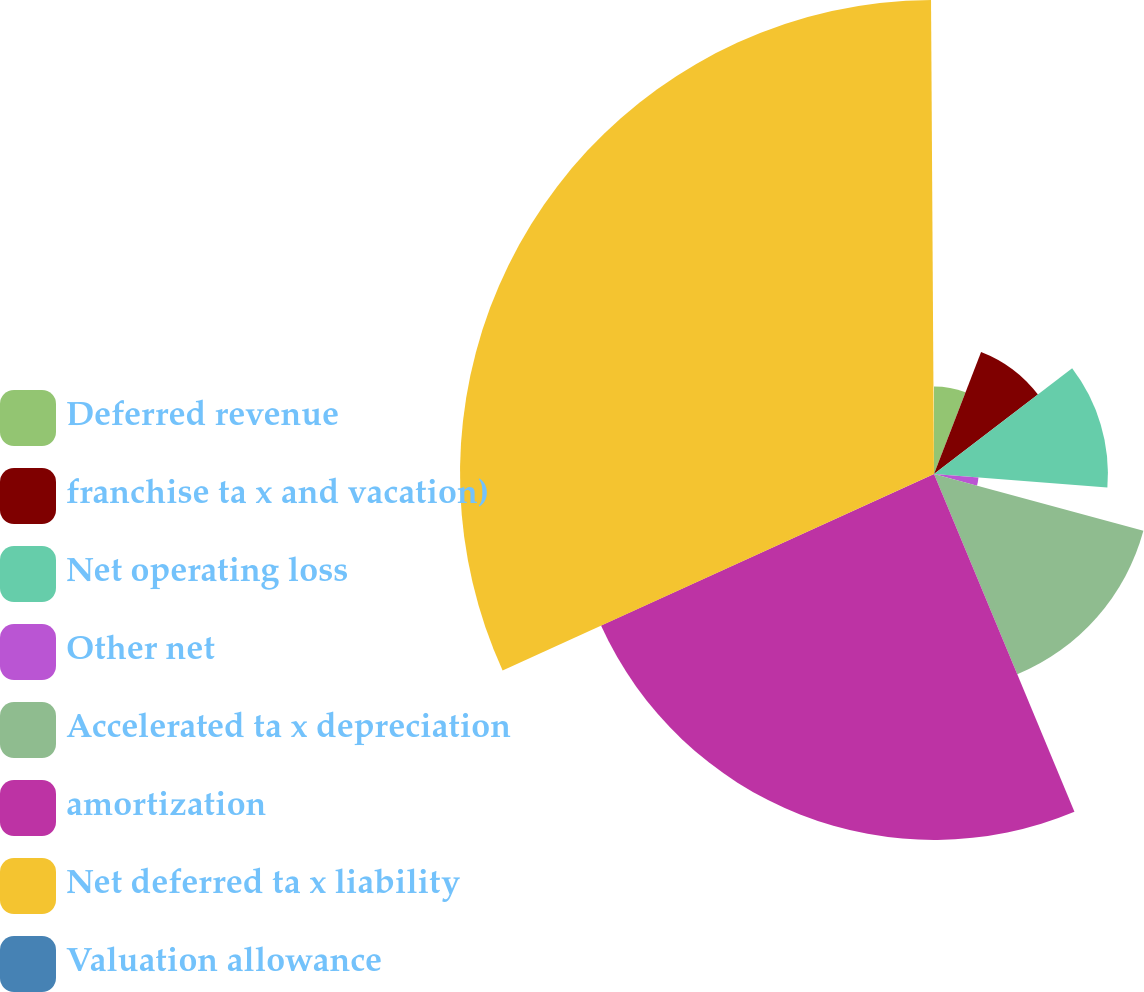Convert chart to OTSL. <chart><loc_0><loc_0><loc_500><loc_500><pie_chart><fcel>Deferred revenue<fcel>franchise ta x and vacation)<fcel>Net operating loss<fcel>Other net<fcel>Accelerated ta x depreciation<fcel>amortization<fcel>Net deferred ta x liability<fcel>Valuation allowance<nl><fcel>5.86%<fcel>8.75%<fcel>11.63%<fcel>2.98%<fcel>14.51%<fcel>24.47%<fcel>31.7%<fcel>0.1%<nl></chart> 